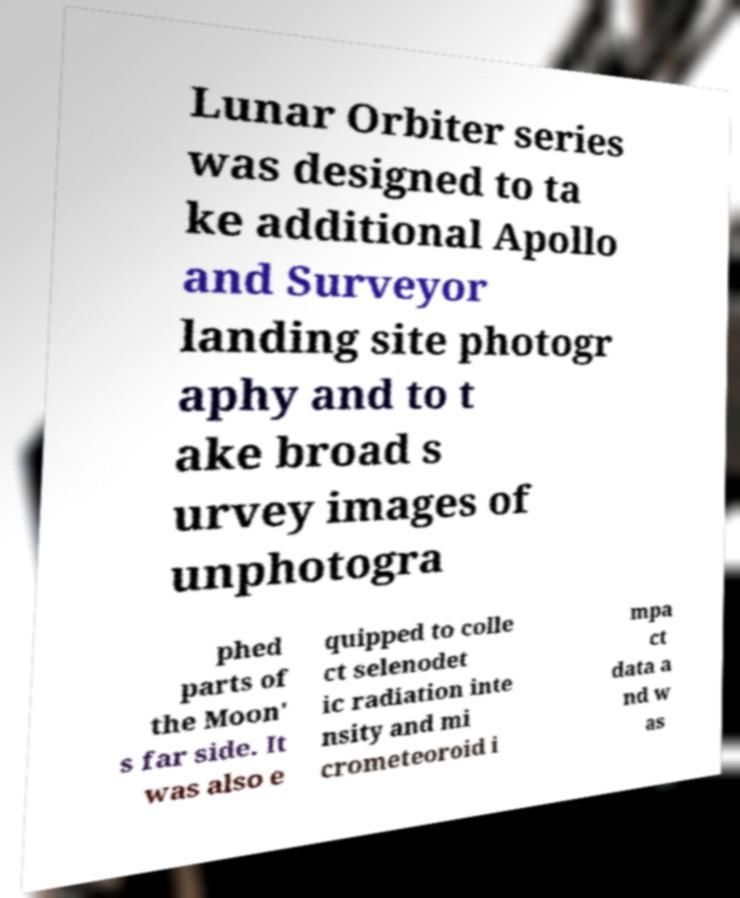Can you read and provide the text displayed in the image?This photo seems to have some interesting text. Can you extract and type it out for me? Lunar Orbiter series was designed to ta ke additional Apollo and Surveyor landing site photogr aphy and to t ake broad s urvey images of unphotogra phed parts of the Moon' s far side. It was also e quipped to colle ct selenodet ic radiation inte nsity and mi crometeoroid i mpa ct data a nd w as 